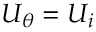<formula> <loc_0><loc_0><loc_500><loc_500>U _ { \theta } = U _ { i }</formula> 